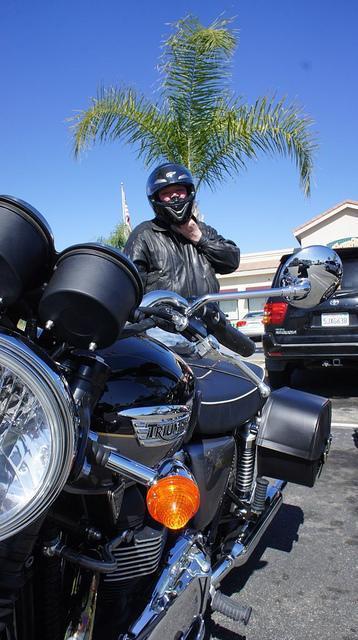How many people are in the photo?
Give a very brief answer. 1. 